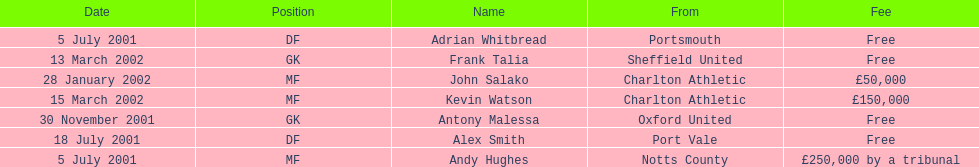What was the transfer fee to transfer kevin watson? £150,000. 